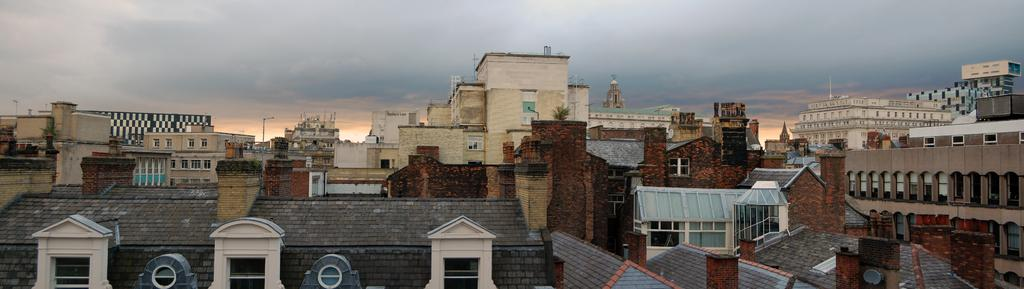What types of structures can be seen in the image? There are buildings and houses in the image. What architectural features are present in the image? There are roofs, pillars, and poles in the image. What natural elements are present in the image? There are plants in the image. What openings can be seen in the structures? There are windows in the image. What type of wall is visible in the image? There is a brick wall in the image. What is visible at the top of the image? The sky is visible at the top of the image. What is the condition of the sky in the image? The sky is cloudy in the image. What type of bread can be seen in the image? There is no bread present in the image. What effect does the story have on the buildings in the image? There is no story mentioned in the image, so it is not possible to determine any effects on the buildings. 